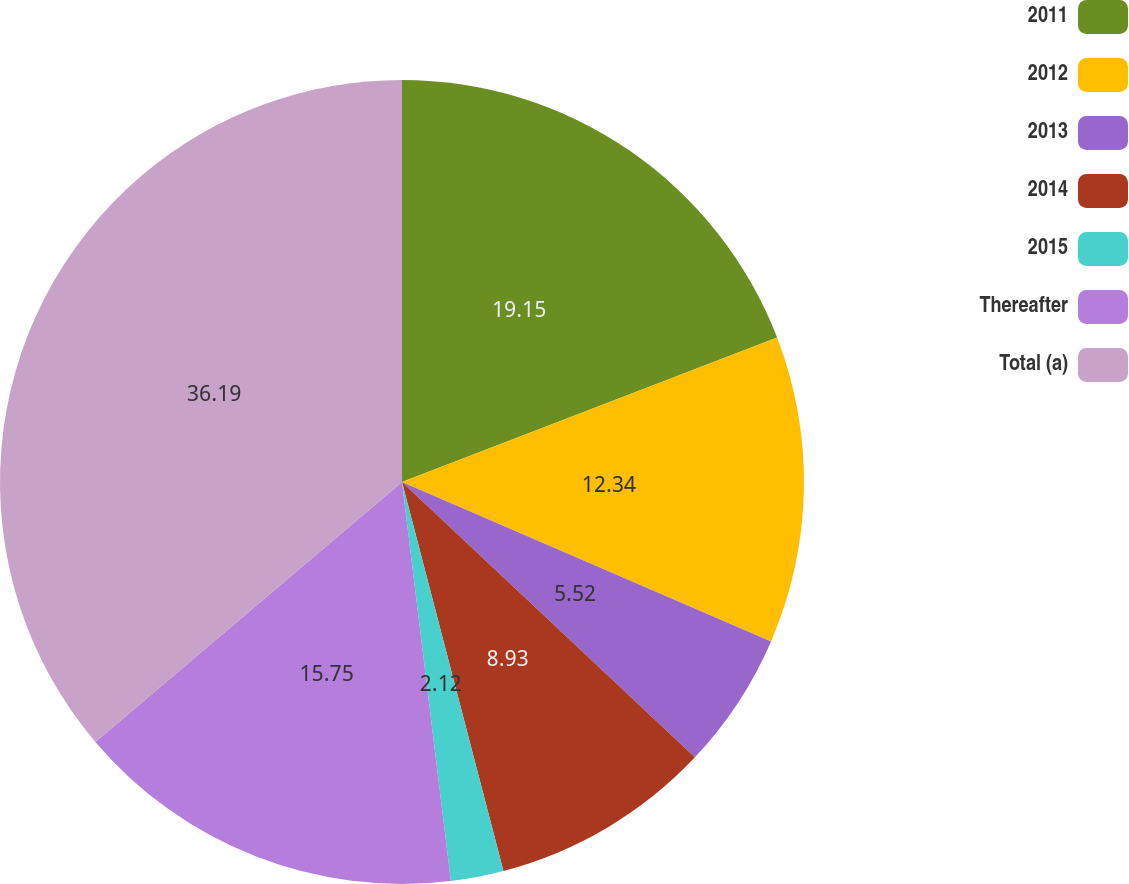Convert chart. <chart><loc_0><loc_0><loc_500><loc_500><pie_chart><fcel>2011<fcel>2012<fcel>2013<fcel>2014<fcel>2015<fcel>Thereafter<fcel>Total (a)<nl><fcel>19.15%<fcel>12.34%<fcel>5.52%<fcel>8.93%<fcel>2.12%<fcel>15.75%<fcel>36.19%<nl></chart> 